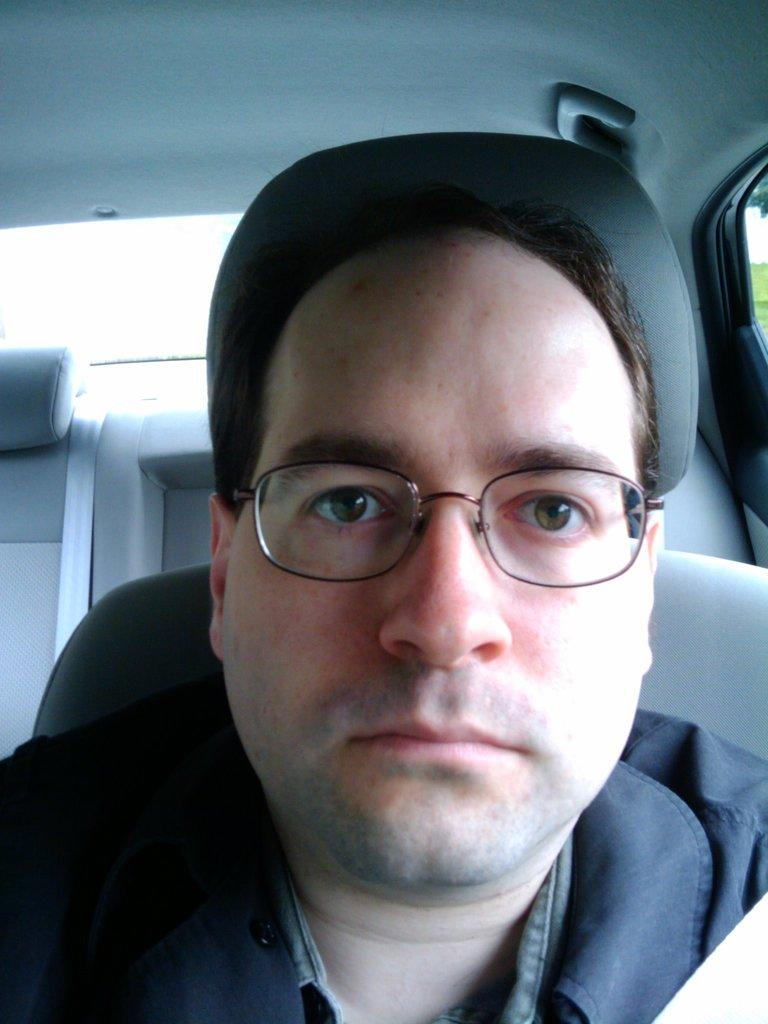What is the person in the image doing? There is a person sitting inside a vehicle in the image. Can you describe any safety features visible in the image? Yes, a seat belt is visible in the background. What type of bomb is being defused in the image? There is no bomb present in the image; it features a person sitting inside a vehicle with a visible seat belt. What direction is the person facing in the image? The direction the person is facing cannot be determined from the image. 